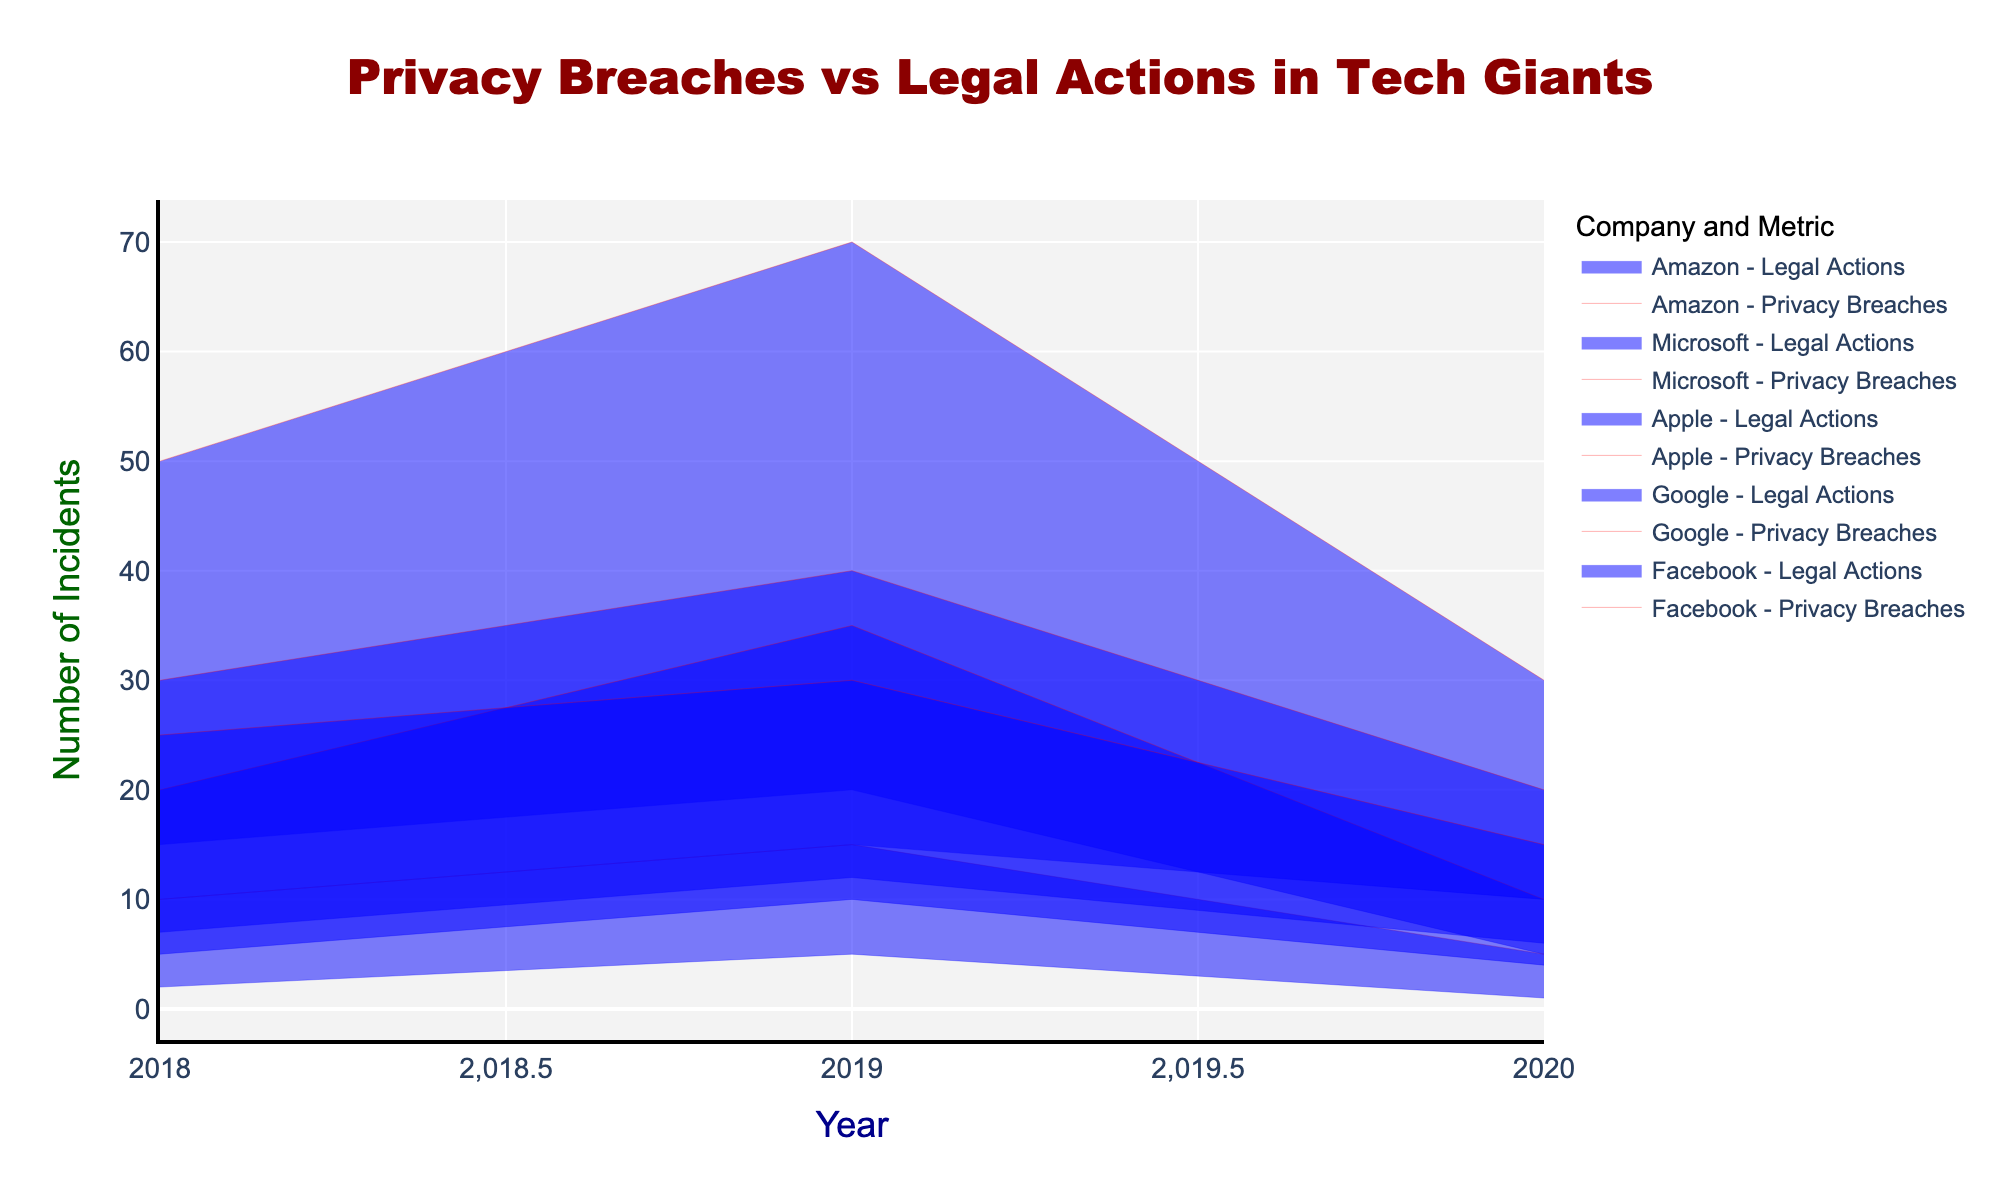What's the title of the figure? The title is located at the top center of the figure and is usually displayed in a larger font size with a different color.
Answer: Privacy Breaches vs Legal Actions in Tech Giants What is the color used for representing privacy breach incidents? The color for privacy breach incidents is visually distinct from the color for legal actions. In the figure, it is a shade of red.
Answer: Red In which year did Facebook experience the highest number of privacy breach incidents? By looking at the red line graph for Facebook, we can identify the peak value. From the figure, the year is 2019.
Answer: 2019 Which company had the lowest number of legal actions taken in 2020? By comparing the blue segments representing legal actions in 2020 across all companies, Apple has the lowest value in 2020.
Answer: Apple How do the privacy breach incidents for Google in 2020 compare to the previous years? By analyzing the red lines for Google, we see a decreasing trend from 2018 to 2020. The value in 2020 is the lowest.
Answer: Decreased Which year saw the highest number of combined privacy breach incidents across all companies? We need to visually sum up the peaks of the red lines across each year. The year 2019 has the highest combined value.
Answer: 2019 What is the total number of legal actions taken by Amazon from 2018 to 2020? For this, sum the blue segments for Amazon over the given years: 7 (2018) + 12 (2019) + 6 (2020) = 25.
Answer: 25 Did Microsoft have more privacy breach incidents or legal actions taken in 2019? By comparing the red and blue lines for Microsoft in 2019, the privacy breach incidents (35) are higher than the legal actions taken (10).
Answer: Privacy Breach Incidents Which company witnessed the greatest reduction in privacy breach incidents in the span of three years (2018-2020)? By evaluating the decrease for each company, Facebook went from 50 (2018) to 30 (2020) showing a significant reduction of 20 incidents.
Answer: Facebook How many privacy breach incidents were reported by Apple in years when they had more than 3 legal actions taken? For apple, the year is 2019 with 5 legal actions and 15 privacy breaches.
Answer: 15 